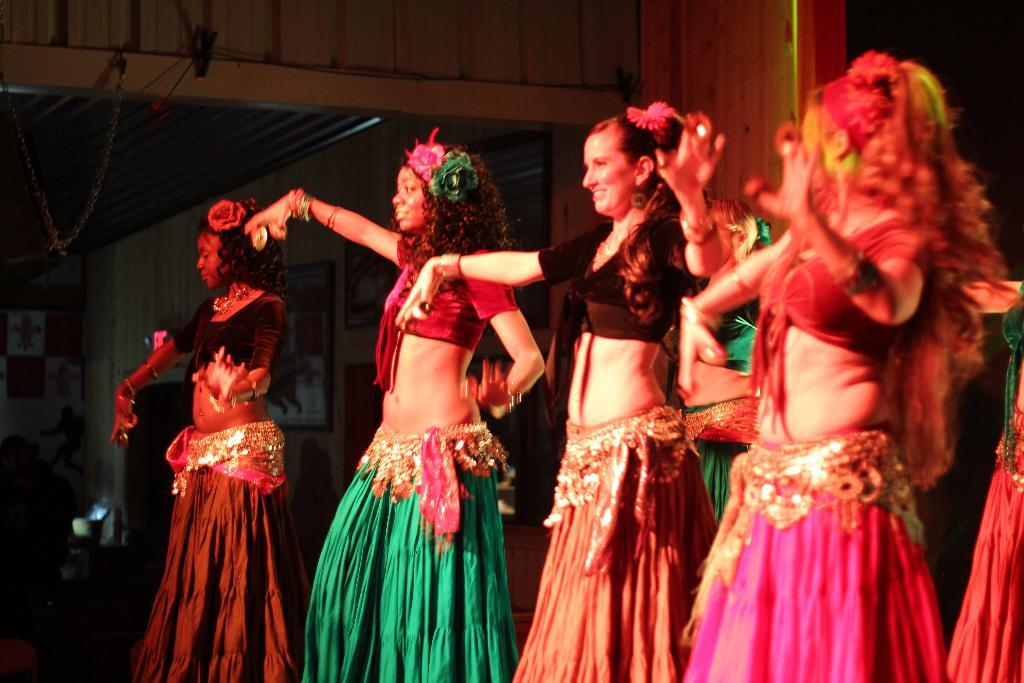What can be seen in the image? There is a group of people in the image. How are the people dressed? The people are wearing different color dresses. What is visible in the background of the image? There are boards on the wall in the background of the image. What type of trousers are the people wearing in the image? The provided facts do not mention any trousers being worn by the people in the image. --- 